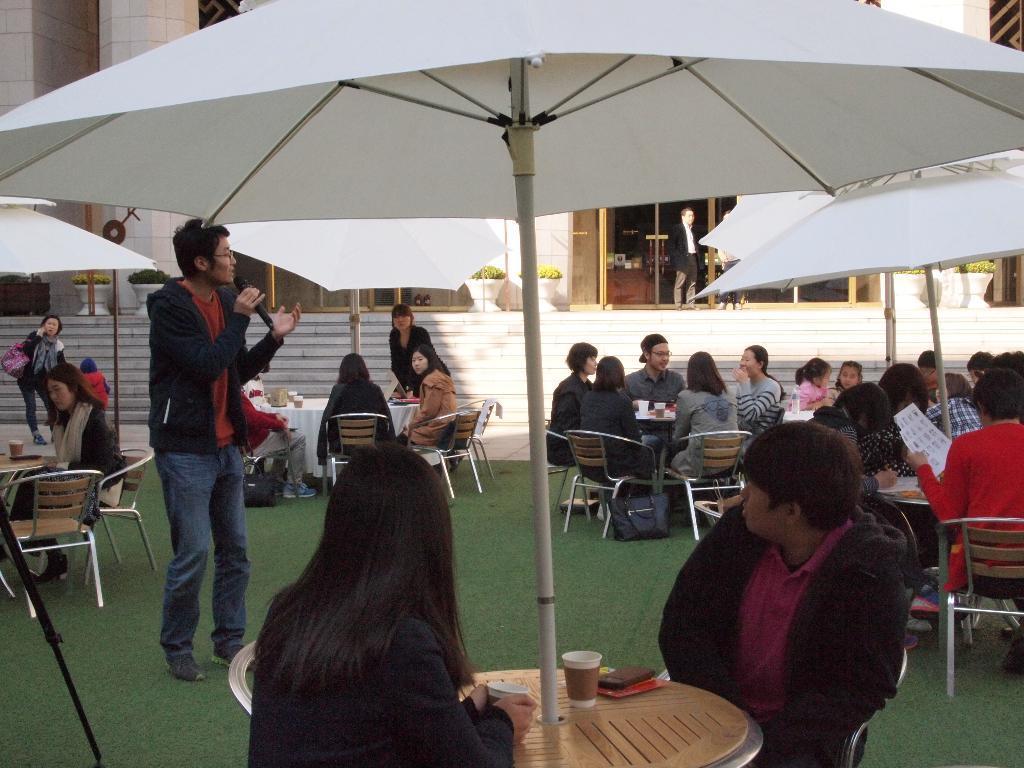How would you summarize this image in a sentence or two? This picture describes about group of people, few are seated and few are standing, in front of them we can see cups and other things on the tables, on the left side of the image we can see a man, he is holding a microphone, and we can see few umbrellas, plants and a building. 